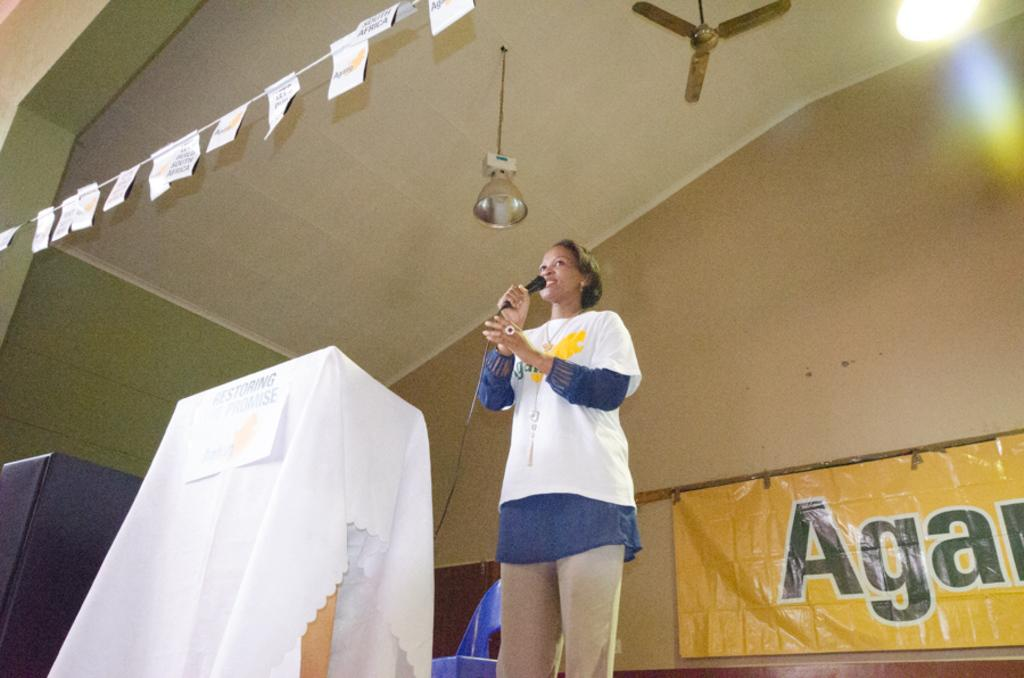<image>
Create a compact narrative representing the image presented. A women speaker standing in front of a banner with Aga on it. 